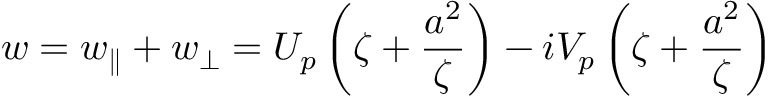Convert formula to latex. <formula><loc_0><loc_0><loc_500><loc_500>w = w _ { \| } + w _ { \perp } = U _ { p } \left ( \zeta + \frac { a ^ { 2 } } { \zeta } \right ) - i V _ { p } \left ( \zeta + \frac { a ^ { 2 } } { \zeta } \right )</formula> 